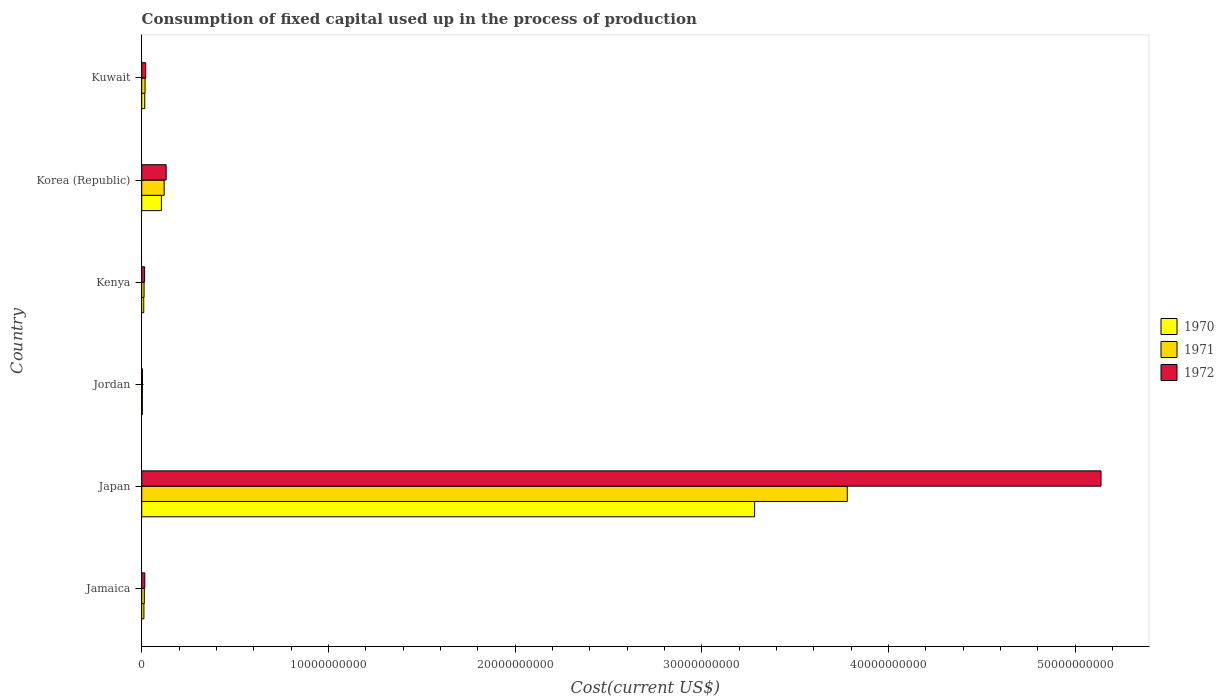How many groups of bars are there?
Offer a terse response. 6. How many bars are there on the 4th tick from the bottom?
Provide a short and direct response. 3. What is the label of the 3rd group of bars from the top?
Your answer should be very brief. Kenya. In how many cases, is the number of bars for a given country not equal to the number of legend labels?
Offer a terse response. 0. What is the amount consumed in the process of production in 1970 in Kuwait?
Provide a short and direct response. 1.62e+08. Across all countries, what is the maximum amount consumed in the process of production in 1970?
Your response must be concise. 3.28e+1. Across all countries, what is the minimum amount consumed in the process of production in 1972?
Ensure brevity in your answer.  3.86e+07. In which country was the amount consumed in the process of production in 1970 maximum?
Your answer should be very brief. Japan. In which country was the amount consumed in the process of production in 1971 minimum?
Ensure brevity in your answer.  Jordan. What is the total amount consumed in the process of production in 1972 in the graph?
Provide a succinct answer. 5.33e+1. What is the difference between the amount consumed in the process of production in 1972 in Korea (Republic) and that in Kuwait?
Offer a very short reply. 1.10e+09. What is the difference between the amount consumed in the process of production in 1970 in Kenya and the amount consumed in the process of production in 1972 in Korea (Republic)?
Keep it short and to the point. -1.20e+09. What is the average amount consumed in the process of production in 1972 per country?
Provide a short and direct response. 8.88e+09. What is the difference between the amount consumed in the process of production in 1972 and amount consumed in the process of production in 1971 in Japan?
Keep it short and to the point. 1.36e+1. What is the ratio of the amount consumed in the process of production in 1971 in Jamaica to that in Kuwait?
Your response must be concise. 0.77. Is the amount consumed in the process of production in 1970 in Jamaica less than that in Korea (Republic)?
Give a very brief answer. Yes. What is the difference between the highest and the second highest amount consumed in the process of production in 1972?
Provide a succinct answer. 5.01e+1. What is the difference between the highest and the lowest amount consumed in the process of production in 1971?
Your answer should be very brief. 3.78e+1. In how many countries, is the amount consumed in the process of production in 1972 greater than the average amount consumed in the process of production in 1972 taken over all countries?
Offer a very short reply. 1. What does the 3rd bar from the top in Japan represents?
Offer a very short reply. 1970. Is it the case that in every country, the sum of the amount consumed in the process of production in 1971 and amount consumed in the process of production in 1970 is greater than the amount consumed in the process of production in 1972?
Provide a short and direct response. Yes. Are all the bars in the graph horizontal?
Give a very brief answer. Yes. How many countries are there in the graph?
Provide a succinct answer. 6. What is the difference between two consecutive major ticks on the X-axis?
Make the answer very short. 1.00e+1. Are the values on the major ticks of X-axis written in scientific E-notation?
Offer a very short reply. No. Does the graph contain any zero values?
Give a very brief answer. No. Does the graph contain grids?
Provide a succinct answer. No. What is the title of the graph?
Your answer should be very brief. Consumption of fixed capital used up in the process of production. What is the label or title of the X-axis?
Your response must be concise. Cost(current US$). What is the label or title of the Y-axis?
Provide a short and direct response. Country. What is the Cost(current US$) in 1970 in Jamaica?
Your response must be concise. 1.17e+08. What is the Cost(current US$) in 1971 in Jamaica?
Give a very brief answer. 1.39e+08. What is the Cost(current US$) of 1972 in Jamaica?
Offer a terse response. 1.65e+08. What is the Cost(current US$) of 1970 in Japan?
Offer a terse response. 3.28e+1. What is the Cost(current US$) in 1971 in Japan?
Your answer should be compact. 3.78e+1. What is the Cost(current US$) of 1972 in Japan?
Provide a short and direct response. 5.14e+1. What is the Cost(current US$) in 1970 in Jordan?
Offer a terse response. 3.46e+07. What is the Cost(current US$) of 1971 in Jordan?
Your answer should be compact. 3.55e+07. What is the Cost(current US$) in 1972 in Jordan?
Provide a short and direct response. 3.86e+07. What is the Cost(current US$) in 1970 in Kenya?
Keep it short and to the point. 1.08e+08. What is the Cost(current US$) of 1971 in Kenya?
Make the answer very short. 1.25e+08. What is the Cost(current US$) in 1972 in Kenya?
Offer a very short reply. 1.55e+08. What is the Cost(current US$) in 1970 in Korea (Republic)?
Offer a very short reply. 1.05e+09. What is the Cost(current US$) in 1971 in Korea (Republic)?
Your answer should be very brief. 1.20e+09. What is the Cost(current US$) of 1972 in Korea (Republic)?
Your response must be concise. 1.31e+09. What is the Cost(current US$) of 1970 in Kuwait?
Offer a terse response. 1.62e+08. What is the Cost(current US$) of 1971 in Kuwait?
Keep it short and to the point. 1.80e+08. What is the Cost(current US$) in 1972 in Kuwait?
Your response must be concise. 2.13e+08. Across all countries, what is the maximum Cost(current US$) in 1970?
Ensure brevity in your answer.  3.28e+1. Across all countries, what is the maximum Cost(current US$) of 1971?
Ensure brevity in your answer.  3.78e+1. Across all countries, what is the maximum Cost(current US$) of 1972?
Provide a succinct answer. 5.14e+1. Across all countries, what is the minimum Cost(current US$) of 1970?
Your answer should be very brief. 3.46e+07. Across all countries, what is the minimum Cost(current US$) of 1971?
Give a very brief answer. 3.55e+07. Across all countries, what is the minimum Cost(current US$) of 1972?
Ensure brevity in your answer.  3.86e+07. What is the total Cost(current US$) of 1970 in the graph?
Ensure brevity in your answer.  3.43e+1. What is the total Cost(current US$) in 1971 in the graph?
Give a very brief answer. 3.95e+1. What is the total Cost(current US$) in 1972 in the graph?
Provide a succinct answer. 5.33e+1. What is the difference between the Cost(current US$) of 1970 in Jamaica and that in Japan?
Offer a terse response. -3.27e+1. What is the difference between the Cost(current US$) of 1971 in Jamaica and that in Japan?
Offer a terse response. -3.77e+1. What is the difference between the Cost(current US$) in 1972 in Jamaica and that in Japan?
Ensure brevity in your answer.  -5.12e+1. What is the difference between the Cost(current US$) in 1970 in Jamaica and that in Jordan?
Ensure brevity in your answer.  8.22e+07. What is the difference between the Cost(current US$) in 1971 in Jamaica and that in Jordan?
Offer a very short reply. 1.04e+08. What is the difference between the Cost(current US$) in 1972 in Jamaica and that in Jordan?
Offer a terse response. 1.26e+08. What is the difference between the Cost(current US$) in 1970 in Jamaica and that in Kenya?
Give a very brief answer. 8.74e+06. What is the difference between the Cost(current US$) in 1971 in Jamaica and that in Kenya?
Your response must be concise. 1.36e+07. What is the difference between the Cost(current US$) in 1972 in Jamaica and that in Kenya?
Your answer should be compact. 1.00e+07. What is the difference between the Cost(current US$) of 1970 in Jamaica and that in Korea (Republic)?
Your answer should be very brief. -9.37e+08. What is the difference between the Cost(current US$) in 1971 in Jamaica and that in Korea (Republic)?
Provide a succinct answer. -1.06e+09. What is the difference between the Cost(current US$) in 1972 in Jamaica and that in Korea (Republic)?
Your answer should be very brief. -1.14e+09. What is the difference between the Cost(current US$) of 1970 in Jamaica and that in Kuwait?
Offer a very short reply. -4.57e+07. What is the difference between the Cost(current US$) in 1971 in Jamaica and that in Kuwait?
Keep it short and to the point. -4.07e+07. What is the difference between the Cost(current US$) of 1972 in Jamaica and that in Kuwait?
Offer a terse response. -4.81e+07. What is the difference between the Cost(current US$) of 1970 in Japan and that in Jordan?
Provide a succinct answer. 3.28e+1. What is the difference between the Cost(current US$) in 1971 in Japan and that in Jordan?
Your answer should be compact. 3.78e+1. What is the difference between the Cost(current US$) in 1972 in Japan and that in Jordan?
Give a very brief answer. 5.14e+1. What is the difference between the Cost(current US$) in 1970 in Japan and that in Kenya?
Make the answer very short. 3.27e+1. What is the difference between the Cost(current US$) in 1971 in Japan and that in Kenya?
Your answer should be very brief. 3.77e+1. What is the difference between the Cost(current US$) of 1972 in Japan and that in Kenya?
Your answer should be very brief. 5.12e+1. What is the difference between the Cost(current US$) in 1970 in Japan and that in Korea (Republic)?
Provide a short and direct response. 3.18e+1. What is the difference between the Cost(current US$) of 1971 in Japan and that in Korea (Republic)?
Offer a terse response. 3.66e+1. What is the difference between the Cost(current US$) in 1972 in Japan and that in Korea (Republic)?
Provide a short and direct response. 5.01e+1. What is the difference between the Cost(current US$) in 1970 in Japan and that in Kuwait?
Ensure brevity in your answer.  3.27e+1. What is the difference between the Cost(current US$) in 1971 in Japan and that in Kuwait?
Offer a terse response. 3.76e+1. What is the difference between the Cost(current US$) of 1972 in Japan and that in Kuwait?
Your answer should be very brief. 5.12e+1. What is the difference between the Cost(current US$) in 1970 in Jordan and that in Kenya?
Offer a terse response. -7.34e+07. What is the difference between the Cost(current US$) in 1971 in Jordan and that in Kenya?
Provide a short and direct response. -9.00e+07. What is the difference between the Cost(current US$) in 1972 in Jordan and that in Kenya?
Make the answer very short. -1.16e+08. What is the difference between the Cost(current US$) of 1970 in Jordan and that in Korea (Republic)?
Provide a succinct answer. -1.02e+09. What is the difference between the Cost(current US$) of 1971 in Jordan and that in Korea (Republic)?
Offer a very short reply. -1.17e+09. What is the difference between the Cost(current US$) of 1972 in Jordan and that in Korea (Republic)?
Keep it short and to the point. -1.27e+09. What is the difference between the Cost(current US$) of 1970 in Jordan and that in Kuwait?
Offer a terse response. -1.28e+08. What is the difference between the Cost(current US$) in 1971 in Jordan and that in Kuwait?
Give a very brief answer. -1.44e+08. What is the difference between the Cost(current US$) in 1972 in Jordan and that in Kuwait?
Offer a terse response. -1.74e+08. What is the difference between the Cost(current US$) in 1970 in Kenya and that in Korea (Republic)?
Give a very brief answer. -9.46e+08. What is the difference between the Cost(current US$) in 1971 in Kenya and that in Korea (Republic)?
Provide a succinct answer. -1.08e+09. What is the difference between the Cost(current US$) of 1972 in Kenya and that in Korea (Republic)?
Ensure brevity in your answer.  -1.15e+09. What is the difference between the Cost(current US$) in 1970 in Kenya and that in Kuwait?
Offer a very short reply. -5.44e+07. What is the difference between the Cost(current US$) in 1971 in Kenya and that in Kuwait?
Provide a short and direct response. -5.42e+07. What is the difference between the Cost(current US$) of 1972 in Kenya and that in Kuwait?
Your response must be concise. -5.82e+07. What is the difference between the Cost(current US$) of 1970 in Korea (Republic) and that in Kuwait?
Provide a succinct answer. 8.92e+08. What is the difference between the Cost(current US$) in 1971 in Korea (Republic) and that in Kuwait?
Your answer should be very brief. 1.02e+09. What is the difference between the Cost(current US$) in 1972 in Korea (Republic) and that in Kuwait?
Give a very brief answer. 1.10e+09. What is the difference between the Cost(current US$) of 1970 in Jamaica and the Cost(current US$) of 1971 in Japan?
Your answer should be compact. -3.77e+1. What is the difference between the Cost(current US$) in 1970 in Jamaica and the Cost(current US$) in 1972 in Japan?
Your answer should be compact. -5.13e+1. What is the difference between the Cost(current US$) in 1971 in Jamaica and the Cost(current US$) in 1972 in Japan?
Your answer should be very brief. -5.13e+1. What is the difference between the Cost(current US$) in 1970 in Jamaica and the Cost(current US$) in 1971 in Jordan?
Your response must be concise. 8.12e+07. What is the difference between the Cost(current US$) in 1970 in Jamaica and the Cost(current US$) in 1972 in Jordan?
Keep it short and to the point. 7.81e+07. What is the difference between the Cost(current US$) of 1971 in Jamaica and the Cost(current US$) of 1972 in Jordan?
Provide a short and direct response. 1.00e+08. What is the difference between the Cost(current US$) of 1970 in Jamaica and the Cost(current US$) of 1971 in Kenya?
Give a very brief answer. -8.73e+06. What is the difference between the Cost(current US$) in 1970 in Jamaica and the Cost(current US$) in 1972 in Kenya?
Give a very brief answer. -3.80e+07. What is the difference between the Cost(current US$) of 1971 in Jamaica and the Cost(current US$) of 1972 in Kenya?
Make the answer very short. -1.57e+07. What is the difference between the Cost(current US$) of 1970 in Jamaica and the Cost(current US$) of 1971 in Korea (Republic)?
Your response must be concise. -1.09e+09. What is the difference between the Cost(current US$) of 1970 in Jamaica and the Cost(current US$) of 1972 in Korea (Republic)?
Your answer should be compact. -1.19e+09. What is the difference between the Cost(current US$) of 1971 in Jamaica and the Cost(current US$) of 1972 in Korea (Republic)?
Your answer should be very brief. -1.17e+09. What is the difference between the Cost(current US$) in 1970 in Jamaica and the Cost(current US$) in 1971 in Kuwait?
Provide a short and direct response. -6.30e+07. What is the difference between the Cost(current US$) of 1970 in Jamaica and the Cost(current US$) of 1972 in Kuwait?
Offer a terse response. -9.62e+07. What is the difference between the Cost(current US$) in 1971 in Jamaica and the Cost(current US$) in 1972 in Kuwait?
Keep it short and to the point. -7.39e+07. What is the difference between the Cost(current US$) of 1970 in Japan and the Cost(current US$) of 1971 in Jordan?
Ensure brevity in your answer.  3.28e+1. What is the difference between the Cost(current US$) of 1970 in Japan and the Cost(current US$) of 1972 in Jordan?
Give a very brief answer. 3.28e+1. What is the difference between the Cost(current US$) in 1971 in Japan and the Cost(current US$) in 1972 in Jordan?
Give a very brief answer. 3.78e+1. What is the difference between the Cost(current US$) of 1970 in Japan and the Cost(current US$) of 1971 in Kenya?
Your answer should be compact. 3.27e+1. What is the difference between the Cost(current US$) of 1970 in Japan and the Cost(current US$) of 1972 in Kenya?
Make the answer very short. 3.27e+1. What is the difference between the Cost(current US$) in 1971 in Japan and the Cost(current US$) in 1972 in Kenya?
Your response must be concise. 3.76e+1. What is the difference between the Cost(current US$) of 1970 in Japan and the Cost(current US$) of 1971 in Korea (Republic)?
Provide a succinct answer. 3.16e+1. What is the difference between the Cost(current US$) in 1970 in Japan and the Cost(current US$) in 1972 in Korea (Republic)?
Provide a short and direct response. 3.15e+1. What is the difference between the Cost(current US$) in 1971 in Japan and the Cost(current US$) in 1972 in Korea (Republic)?
Keep it short and to the point. 3.65e+1. What is the difference between the Cost(current US$) in 1970 in Japan and the Cost(current US$) in 1971 in Kuwait?
Your answer should be compact. 3.27e+1. What is the difference between the Cost(current US$) of 1970 in Japan and the Cost(current US$) of 1972 in Kuwait?
Give a very brief answer. 3.26e+1. What is the difference between the Cost(current US$) of 1971 in Japan and the Cost(current US$) of 1972 in Kuwait?
Make the answer very short. 3.76e+1. What is the difference between the Cost(current US$) in 1970 in Jordan and the Cost(current US$) in 1971 in Kenya?
Keep it short and to the point. -9.09e+07. What is the difference between the Cost(current US$) in 1970 in Jordan and the Cost(current US$) in 1972 in Kenya?
Offer a very short reply. -1.20e+08. What is the difference between the Cost(current US$) in 1971 in Jordan and the Cost(current US$) in 1972 in Kenya?
Your response must be concise. -1.19e+08. What is the difference between the Cost(current US$) of 1970 in Jordan and the Cost(current US$) of 1971 in Korea (Republic)?
Provide a short and direct response. -1.17e+09. What is the difference between the Cost(current US$) of 1970 in Jordan and the Cost(current US$) of 1972 in Korea (Republic)?
Your answer should be very brief. -1.27e+09. What is the difference between the Cost(current US$) in 1971 in Jordan and the Cost(current US$) in 1972 in Korea (Republic)?
Your answer should be very brief. -1.27e+09. What is the difference between the Cost(current US$) of 1970 in Jordan and the Cost(current US$) of 1971 in Kuwait?
Ensure brevity in your answer.  -1.45e+08. What is the difference between the Cost(current US$) of 1970 in Jordan and the Cost(current US$) of 1972 in Kuwait?
Provide a succinct answer. -1.78e+08. What is the difference between the Cost(current US$) of 1971 in Jordan and the Cost(current US$) of 1972 in Kuwait?
Offer a terse response. -1.77e+08. What is the difference between the Cost(current US$) in 1970 in Kenya and the Cost(current US$) in 1971 in Korea (Republic)?
Your response must be concise. -1.09e+09. What is the difference between the Cost(current US$) in 1970 in Kenya and the Cost(current US$) in 1972 in Korea (Republic)?
Offer a very short reply. -1.20e+09. What is the difference between the Cost(current US$) in 1971 in Kenya and the Cost(current US$) in 1972 in Korea (Republic)?
Your response must be concise. -1.18e+09. What is the difference between the Cost(current US$) of 1970 in Kenya and the Cost(current US$) of 1971 in Kuwait?
Offer a very short reply. -7.17e+07. What is the difference between the Cost(current US$) in 1970 in Kenya and the Cost(current US$) in 1972 in Kuwait?
Your answer should be compact. -1.05e+08. What is the difference between the Cost(current US$) of 1971 in Kenya and the Cost(current US$) of 1972 in Kuwait?
Keep it short and to the point. -8.75e+07. What is the difference between the Cost(current US$) in 1970 in Korea (Republic) and the Cost(current US$) in 1971 in Kuwait?
Keep it short and to the point. 8.74e+08. What is the difference between the Cost(current US$) in 1970 in Korea (Republic) and the Cost(current US$) in 1972 in Kuwait?
Give a very brief answer. 8.41e+08. What is the difference between the Cost(current US$) in 1971 in Korea (Republic) and the Cost(current US$) in 1972 in Kuwait?
Offer a very short reply. 9.89e+08. What is the average Cost(current US$) in 1970 per country?
Offer a terse response. 5.72e+09. What is the average Cost(current US$) in 1971 per country?
Your answer should be compact. 6.58e+09. What is the average Cost(current US$) in 1972 per country?
Your response must be concise. 8.88e+09. What is the difference between the Cost(current US$) in 1970 and Cost(current US$) in 1971 in Jamaica?
Provide a succinct answer. -2.23e+07. What is the difference between the Cost(current US$) in 1970 and Cost(current US$) in 1972 in Jamaica?
Your response must be concise. -4.81e+07. What is the difference between the Cost(current US$) of 1971 and Cost(current US$) of 1972 in Jamaica?
Make the answer very short. -2.58e+07. What is the difference between the Cost(current US$) in 1970 and Cost(current US$) in 1971 in Japan?
Provide a succinct answer. -4.97e+09. What is the difference between the Cost(current US$) of 1970 and Cost(current US$) of 1972 in Japan?
Make the answer very short. -1.86e+1. What is the difference between the Cost(current US$) in 1971 and Cost(current US$) in 1972 in Japan?
Offer a terse response. -1.36e+1. What is the difference between the Cost(current US$) of 1970 and Cost(current US$) of 1971 in Jordan?
Offer a terse response. -9.20e+05. What is the difference between the Cost(current US$) in 1970 and Cost(current US$) in 1972 in Jordan?
Provide a succinct answer. -4.07e+06. What is the difference between the Cost(current US$) of 1971 and Cost(current US$) of 1972 in Jordan?
Ensure brevity in your answer.  -3.15e+06. What is the difference between the Cost(current US$) of 1970 and Cost(current US$) of 1971 in Kenya?
Make the answer very short. -1.75e+07. What is the difference between the Cost(current US$) of 1970 and Cost(current US$) of 1972 in Kenya?
Make the answer very short. -4.68e+07. What is the difference between the Cost(current US$) in 1971 and Cost(current US$) in 1972 in Kenya?
Your response must be concise. -2.93e+07. What is the difference between the Cost(current US$) in 1970 and Cost(current US$) in 1971 in Korea (Republic)?
Offer a terse response. -1.48e+08. What is the difference between the Cost(current US$) in 1970 and Cost(current US$) in 1972 in Korea (Republic)?
Offer a terse response. -2.55e+08. What is the difference between the Cost(current US$) of 1971 and Cost(current US$) of 1972 in Korea (Republic)?
Ensure brevity in your answer.  -1.08e+08. What is the difference between the Cost(current US$) of 1970 and Cost(current US$) of 1971 in Kuwait?
Your response must be concise. -1.73e+07. What is the difference between the Cost(current US$) of 1970 and Cost(current US$) of 1972 in Kuwait?
Provide a succinct answer. -5.05e+07. What is the difference between the Cost(current US$) of 1971 and Cost(current US$) of 1972 in Kuwait?
Offer a terse response. -3.32e+07. What is the ratio of the Cost(current US$) in 1970 in Jamaica to that in Japan?
Provide a short and direct response. 0. What is the ratio of the Cost(current US$) of 1971 in Jamaica to that in Japan?
Your response must be concise. 0. What is the ratio of the Cost(current US$) in 1972 in Jamaica to that in Japan?
Give a very brief answer. 0. What is the ratio of the Cost(current US$) of 1970 in Jamaica to that in Jordan?
Provide a succinct answer. 3.38. What is the ratio of the Cost(current US$) in 1971 in Jamaica to that in Jordan?
Your answer should be very brief. 3.92. What is the ratio of the Cost(current US$) of 1972 in Jamaica to that in Jordan?
Your answer should be compact. 4.26. What is the ratio of the Cost(current US$) in 1970 in Jamaica to that in Kenya?
Ensure brevity in your answer.  1.08. What is the ratio of the Cost(current US$) in 1971 in Jamaica to that in Kenya?
Your answer should be compact. 1.11. What is the ratio of the Cost(current US$) in 1972 in Jamaica to that in Kenya?
Offer a very short reply. 1.06. What is the ratio of the Cost(current US$) in 1970 in Jamaica to that in Korea (Republic)?
Keep it short and to the point. 0.11. What is the ratio of the Cost(current US$) of 1971 in Jamaica to that in Korea (Republic)?
Provide a short and direct response. 0.12. What is the ratio of the Cost(current US$) of 1972 in Jamaica to that in Korea (Republic)?
Provide a succinct answer. 0.13. What is the ratio of the Cost(current US$) in 1970 in Jamaica to that in Kuwait?
Your response must be concise. 0.72. What is the ratio of the Cost(current US$) in 1971 in Jamaica to that in Kuwait?
Offer a very short reply. 0.77. What is the ratio of the Cost(current US$) in 1972 in Jamaica to that in Kuwait?
Your answer should be compact. 0.77. What is the ratio of the Cost(current US$) of 1970 in Japan to that in Jordan?
Offer a terse response. 949.54. What is the ratio of the Cost(current US$) of 1971 in Japan to that in Jordan?
Your answer should be compact. 1064.79. What is the ratio of the Cost(current US$) of 1972 in Japan to that in Jordan?
Offer a very short reply. 1329.83. What is the ratio of the Cost(current US$) of 1970 in Japan to that in Kenya?
Your answer should be very brief. 304.02. What is the ratio of the Cost(current US$) of 1971 in Japan to that in Kenya?
Offer a very short reply. 301.26. What is the ratio of the Cost(current US$) in 1972 in Japan to that in Kenya?
Offer a terse response. 332.03. What is the ratio of the Cost(current US$) in 1970 in Japan to that in Korea (Republic)?
Offer a terse response. 31.15. What is the ratio of the Cost(current US$) in 1971 in Japan to that in Korea (Republic)?
Give a very brief answer. 31.45. What is the ratio of the Cost(current US$) of 1972 in Japan to that in Korea (Republic)?
Offer a terse response. 39.25. What is the ratio of the Cost(current US$) of 1970 in Japan to that in Kuwait?
Your answer should be compact. 202.13. What is the ratio of the Cost(current US$) in 1971 in Japan to that in Kuwait?
Make the answer very short. 210.36. What is the ratio of the Cost(current US$) in 1972 in Japan to that in Kuwait?
Give a very brief answer. 241.35. What is the ratio of the Cost(current US$) in 1970 in Jordan to that in Kenya?
Make the answer very short. 0.32. What is the ratio of the Cost(current US$) in 1971 in Jordan to that in Kenya?
Give a very brief answer. 0.28. What is the ratio of the Cost(current US$) in 1972 in Jordan to that in Kenya?
Make the answer very short. 0.25. What is the ratio of the Cost(current US$) in 1970 in Jordan to that in Korea (Republic)?
Provide a short and direct response. 0.03. What is the ratio of the Cost(current US$) in 1971 in Jordan to that in Korea (Republic)?
Your answer should be very brief. 0.03. What is the ratio of the Cost(current US$) in 1972 in Jordan to that in Korea (Republic)?
Ensure brevity in your answer.  0.03. What is the ratio of the Cost(current US$) of 1970 in Jordan to that in Kuwait?
Keep it short and to the point. 0.21. What is the ratio of the Cost(current US$) of 1971 in Jordan to that in Kuwait?
Keep it short and to the point. 0.2. What is the ratio of the Cost(current US$) of 1972 in Jordan to that in Kuwait?
Your answer should be compact. 0.18. What is the ratio of the Cost(current US$) of 1970 in Kenya to that in Korea (Republic)?
Offer a very short reply. 0.1. What is the ratio of the Cost(current US$) of 1971 in Kenya to that in Korea (Republic)?
Keep it short and to the point. 0.1. What is the ratio of the Cost(current US$) in 1972 in Kenya to that in Korea (Republic)?
Make the answer very short. 0.12. What is the ratio of the Cost(current US$) of 1970 in Kenya to that in Kuwait?
Provide a short and direct response. 0.66. What is the ratio of the Cost(current US$) of 1971 in Kenya to that in Kuwait?
Provide a short and direct response. 0.7. What is the ratio of the Cost(current US$) of 1972 in Kenya to that in Kuwait?
Give a very brief answer. 0.73. What is the ratio of the Cost(current US$) in 1970 in Korea (Republic) to that in Kuwait?
Provide a short and direct response. 6.49. What is the ratio of the Cost(current US$) of 1971 in Korea (Republic) to that in Kuwait?
Provide a short and direct response. 6.69. What is the ratio of the Cost(current US$) of 1972 in Korea (Republic) to that in Kuwait?
Offer a very short reply. 6.15. What is the difference between the highest and the second highest Cost(current US$) of 1970?
Offer a very short reply. 3.18e+1. What is the difference between the highest and the second highest Cost(current US$) of 1971?
Your response must be concise. 3.66e+1. What is the difference between the highest and the second highest Cost(current US$) of 1972?
Ensure brevity in your answer.  5.01e+1. What is the difference between the highest and the lowest Cost(current US$) in 1970?
Offer a very short reply. 3.28e+1. What is the difference between the highest and the lowest Cost(current US$) of 1971?
Ensure brevity in your answer.  3.78e+1. What is the difference between the highest and the lowest Cost(current US$) of 1972?
Offer a very short reply. 5.14e+1. 